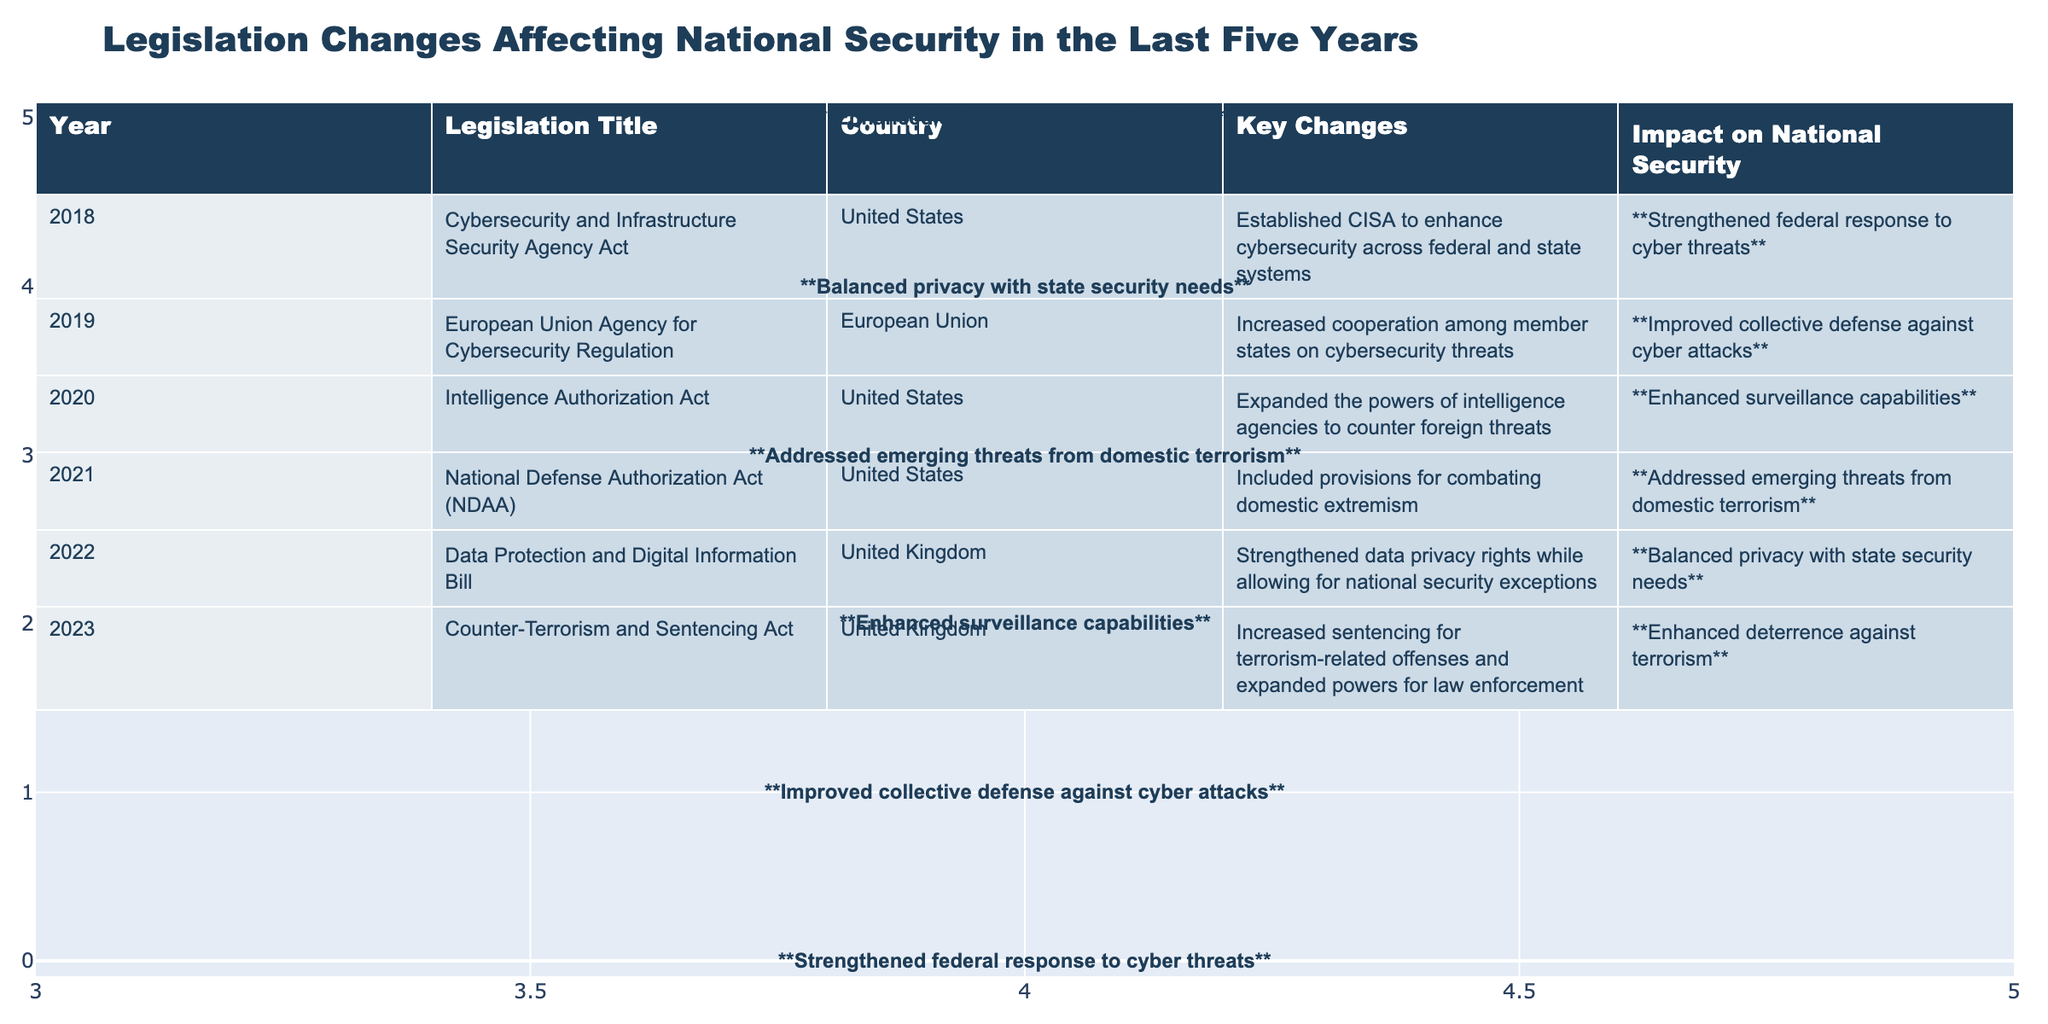What year was the Cybersecurity and Infrastructure Security Agency Act enacted? The table indicates that the Cybersecurity and Infrastructure Security Agency Act was enacted in 2018. This is found in the "Year" column corresponding to this specific legislation.
Answer: 2018 Which legislation increased cooperation among EU member states on cybersecurity threats? The table shows that the "European Union Agency for Cybersecurity Regulation" is the legislation that increased cooperation among member states, as stated in the "Key Changes" column.
Answer: European Union Agency for Cybersecurity Regulation What was the impact on national security of the Intelligence Authorization Act? According to the table, the impact was "Enhanced surveillance capabilities.” This is found in the "Impact on National Security" column for that legislation.
Answer: Enhanced surveillance capabilities Was there any legislation directed at addressing domestic extremism? The table confirms that the "National Defense Authorization Act (NDAA)" included provisions for combating domestic extremism, indicating a direct focus on this issue.
Answer: Yes What is the total number of pieces of legislation enacted by the United States related to national security in the last five years? The table lists three pieces of legislation enacted by the United States: the Cybersecurity and Infrastructure Security Agency Act (2018), the Intelligence Authorization Act (2020), and the National Defense Authorization Act (2021). Therefore, by counting these, the total is three.
Answer: 3 Which country implemented the Data Protection and Digital Information Bill, and what was its key focus? The table states that the Data Protection and Digital Information Bill was enacted in the United Kingdom, with its key focus being the strengthening of data privacy rights while allowing for national security exceptions, as indicated in the "Key Changes" column.
Answer: United Kingdom; strengthening data privacy rights What year saw the introduction of legislation that enhanced deterrence against terrorism? The table indicates that the "Counter-Terrorism and Sentencing Act," which enhanced deterrence against terrorism, was enacted in 2023. This is noted in the "Year" column for that legislation.
Answer: 2023 How many countries are represented in the data provided regarding national security legislation? The data indicates legislation from two countries: the United States and the United Kingdom, along with legislation from the European Union. Thus, there are three distinct entities represented in the data.
Answer: 3 What was the primary focus of the Counter-Terrorism and Sentencing Act? According to the table, the Counter-Terrorism and Sentencing Act primarily focused on increasing sentencing for terrorism-related offenses and expanding powers for law enforcement, which is found in the "Key Changes" column.
Answer: Increased sentencing for terrorism-related offenses If you consider all the key changes, which impact on national security was focused on balancing privacy with state security needs? The table specifies that the "Data Protection and Digital Information Bill" had the impact of balancing privacy with state security needs, indicating a complex interplay between these two aspects.
Answer: Balanced privacy with state security needs 